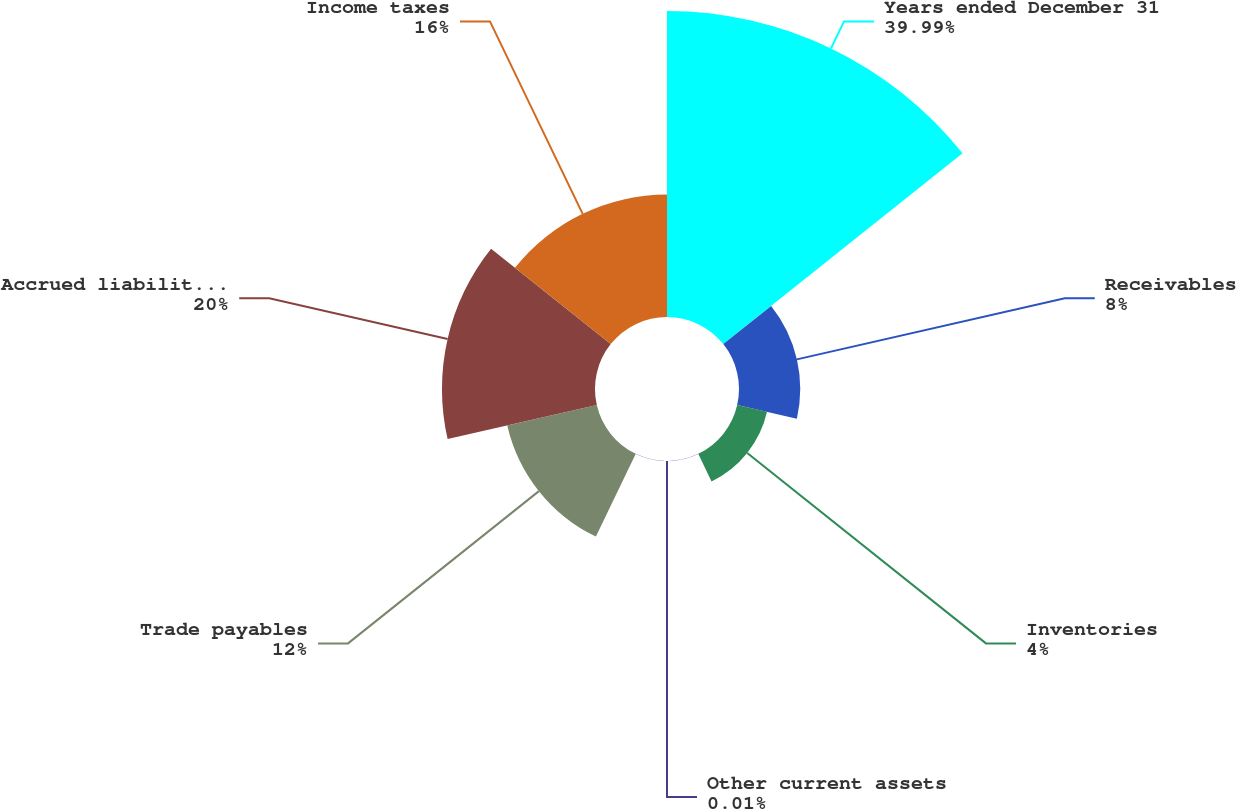<chart> <loc_0><loc_0><loc_500><loc_500><pie_chart><fcel>Years ended December 31<fcel>Receivables<fcel>Inventories<fcel>Other current assets<fcel>Trade payables<fcel>Accrued liabilities including<fcel>Income taxes<nl><fcel>39.99%<fcel>8.0%<fcel>4.0%<fcel>0.01%<fcel>12.0%<fcel>20.0%<fcel>16.0%<nl></chart> 